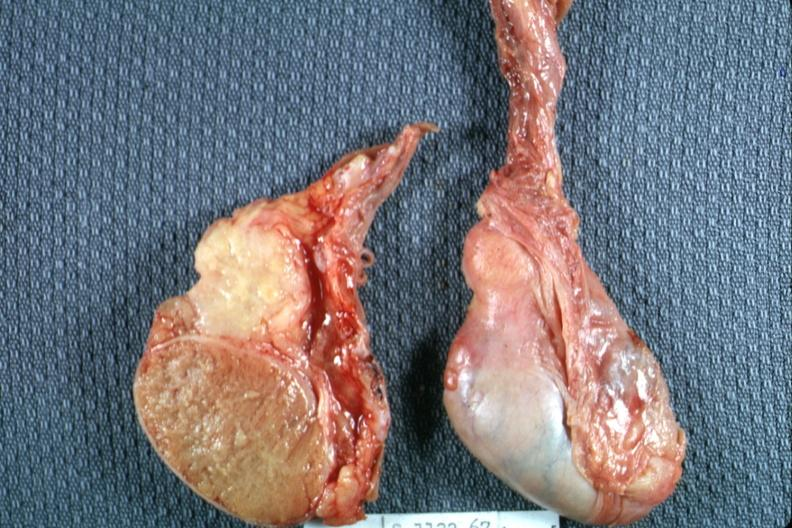does this image show excellent view of cut surface and unopened surface?
Answer the question using a single word or phrase. Yes 